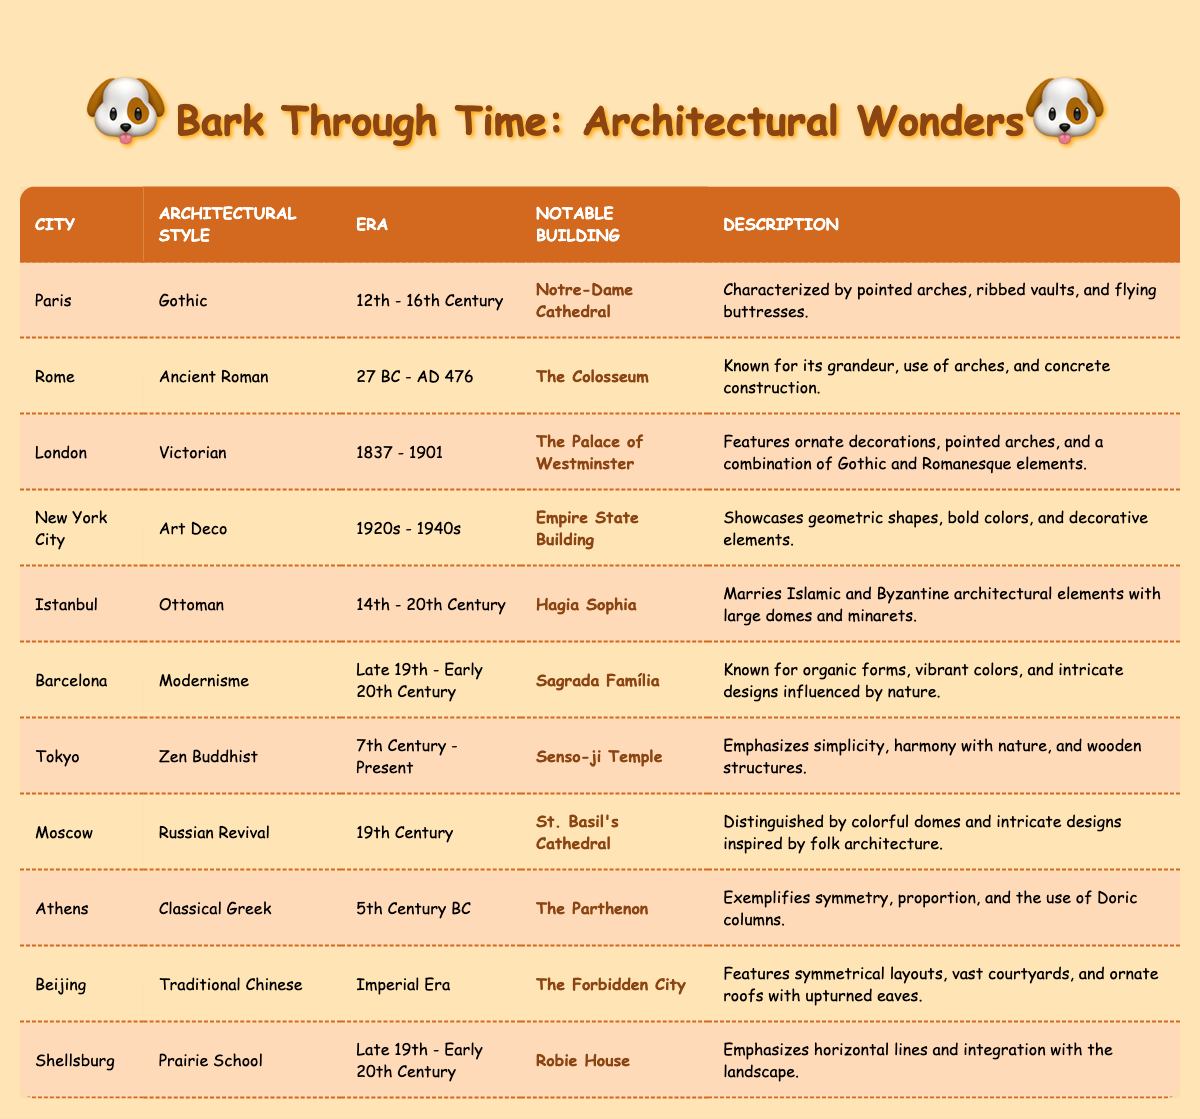What architectural style is associated with the Empire State Building? The Empire State Building is located in New York City and is associated with the Art Deco architectural style. This can be found by looking at the "Architectural Style" column related to the "City" of New York City.
Answer: Art Deco Which notable building represents the Classical Greek architectural style? The notable building that represents the Classical Greek architectural style is The Parthenon. This is found by identifying the appropriate row where "Architectural Style" is Classical Greek.
Answer: The Parthenon Is the Senso-ji Temple located in Tokyo? Yes, the Senso-ji Temple is indeed located in Tokyo as per the table. This can be confirmed by looking for Tokyo in the "City" column.
Answer: Yes How many architectural styles are represented in the table that span the 19th century? The table shows two architectural styles that span the 19th century: Russian Revival (19th Century) and Victorian (1837 - 1901). Both can be counted from the "Era" column. In total, that's two styles.
Answer: 2 Does the city of Shellsburg feature any architectural style earlier than the 19th century? No, Shellsburg features the Prairie School, which is categorized as being from the Late 19th - Early 20th Century, indicating that there are no earlier styles associated with it in the table.
Answer: No Which city features an architectural style that is a mixture of Islamic and Byzantine elements? Istanbul features the Ottoman architectural style, which is described as marrying Islamic and Byzantine architectural elements. This information can be found in the corresponding row under the "Architectural Style" for Istanbul.
Answer: Istanbul Which architectural style is characterized by horizontal lines and integration with the landscape? The Prairie School architectural style is characterized by horizontal lines and integration with the landscape, specifically mentioned in relation to Robie House in the table.
Answer: Prairie School What is the notable building associated with the Russian Revival style? The notable building associated with the Russian Revival style is St. Basil's Cathedral. This can be identified from the row corresponding to Moscow under the "Notable Building" column.
Answer: St. Basil's Cathedral Which city has an architectural style known for vibrant colors and organic forms? Barcelona is associated with the Modernisme architectural style, which is known for vibrant colors and organic forms. This can be confirmed by looking at the "Architectural Style" column for Barcelona.
Answer: Barcelona 